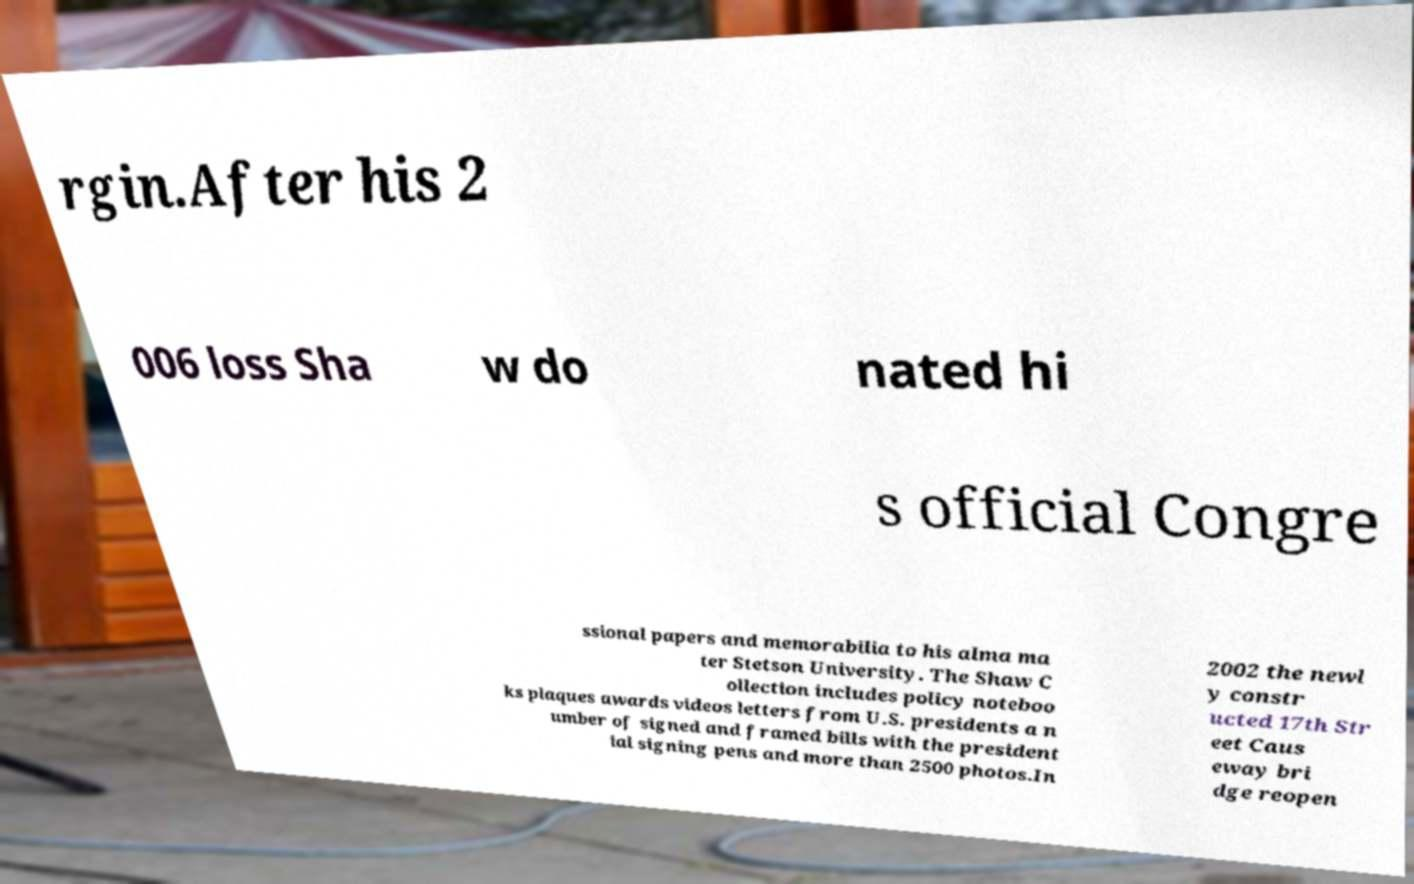Can you accurately transcribe the text from the provided image for me? rgin.After his 2 006 loss Sha w do nated hi s official Congre ssional papers and memorabilia to his alma ma ter Stetson University. The Shaw C ollection includes policy noteboo ks plaques awards videos letters from U.S. presidents a n umber of signed and framed bills with the president ial signing pens and more than 2500 photos.In 2002 the newl y constr ucted 17th Str eet Caus eway bri dge reopen 